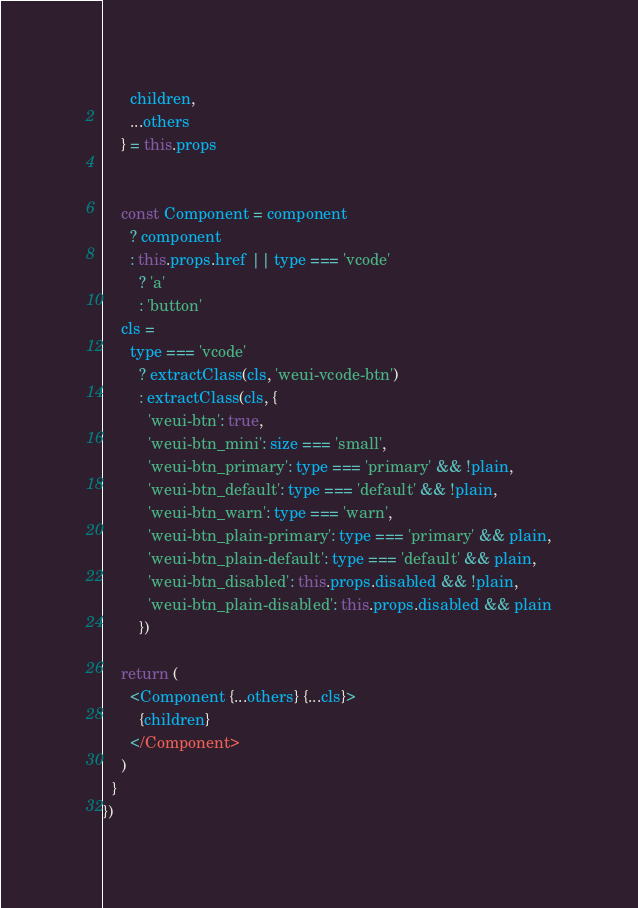Convert code to text. <code><loc_0><loc_0><loc_500><loc_500><_JavaScript_>      children,
      ...others
    } = this.props


    const Component = component
      ? component
      : this.props.href || type === 'vcode'
        ? 'a'
        : 'button'
    cls =
      type === 'vcode'
        ? extractClass(cls, 'weui-vcode-btn')
        : extractClass(cls, {
          'weui-btn': true,
          'weui-btn_mini': size === 'small',
          'weui-btn_primary': type === 'primary' && !plain,
          'weui-btn_default': type === 'default' && !plain,
          'weui-btn_warn': type === 'warn',
          'weui-btn_plain-primary': type === 'primary' && plain,
          'weui-btn_plain-default': type === 'default' && plain,
          'weui-btn_disabled': this.props.disabled && !plain,
          'weui-btn_plain-disabled': this.props.disabled && plain
        })

    return (
      <Component {...others} {...cls}>
        {children}
      </Component>
    )
  }
})
</code> 